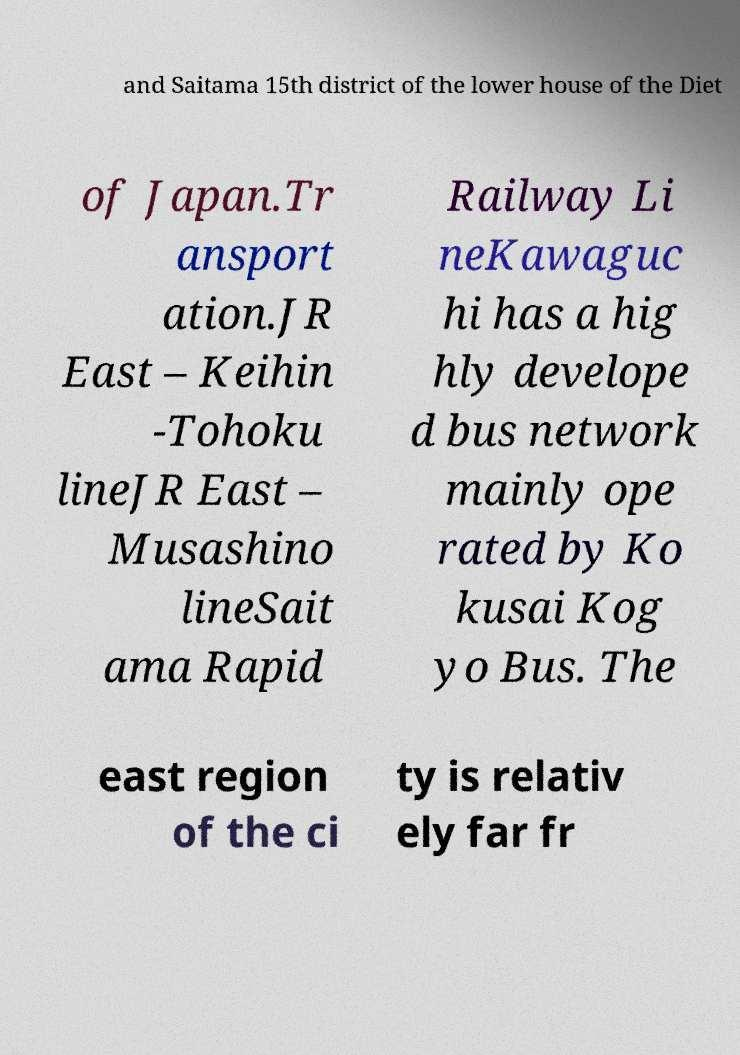For documentation purposes, I need the text within this image transcribed. Could you provide that? and Saitama 15th district of the lower house of the Diet of Japan.Tr ansport ation.JR East – Keihin -Tohoku lineJR East – Musashino lineSait ama Rapid Railway Li neKawaguc hi has a hig hly develope d bus network mainly ope rated by Ko kusai Kog yo Bus. The east region of the ci ty is relativ ely far fr 